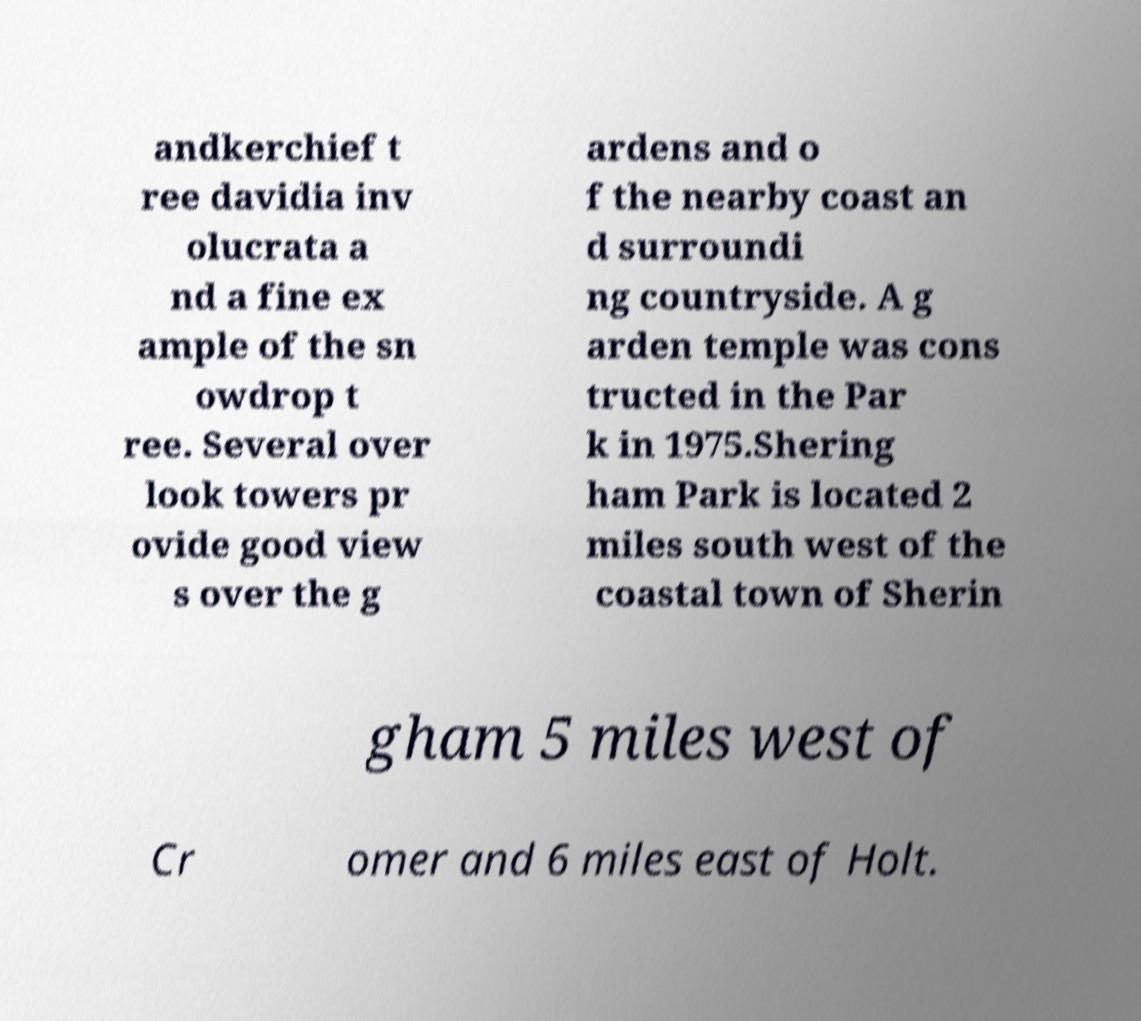Could you extract and type out the text from this image? andkerchief t ree davidia inv olucrata a nd a fine ex ample of the sn owdrop t ree. Several over look towers pr ovide good view s over the g ardens and o f the nearby coast an d surroundi ng countryside. A g arden temple was cons tructed in the Par k in 1975.Shering ham Park is located 2 miles south west of the coastal town of Sherin gham 5 miles west of Cr omer and 6 miles east of Holt. 